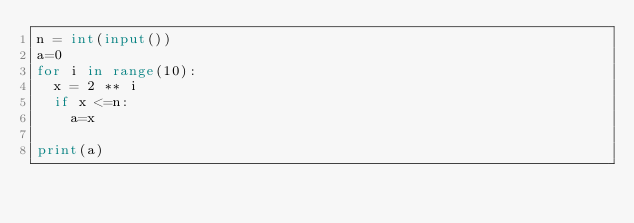Convert code to text. <code><loc_0><loc_0><loc_500><loc_500><_Python_>n = int(input())
a=0
for i in range(10):
  x = 2 ** i
  if x <=n:
    a=x
    
print(a)</code> 